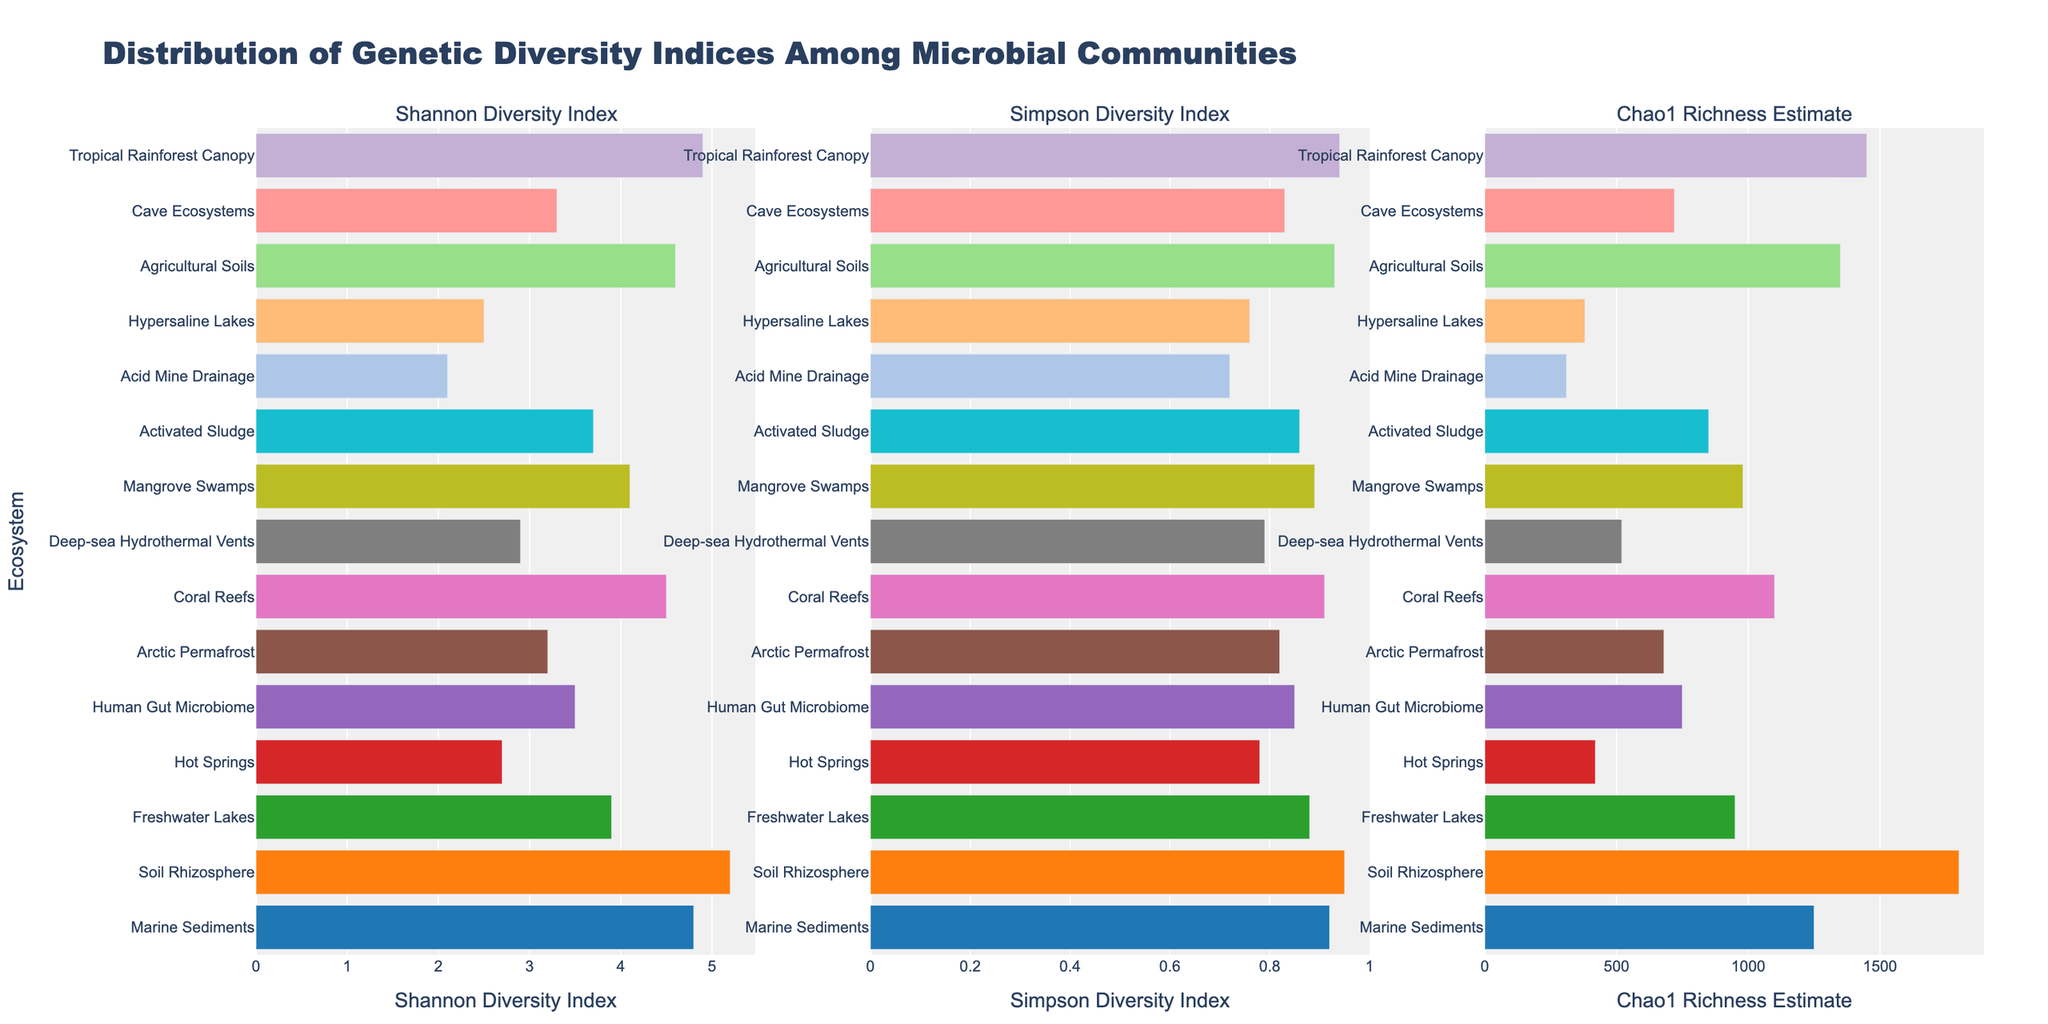Which ecosystem has the highest Shannon Diversity Index? To determine the ecosystem with the highest Shannon Diversity Index, look for the bar that extends the farthest to the right in the Shannon Diversity Index subplot. The Soil Rhizosphere bar is the longest, which represents a Shannon Diversity Index of 5.2.
Answer: Soil Rhizosphere Which ecosystem has the lowest Simpson Diversity Index? To identify the ecosystem with the lowest Simpson Diversity Index, observe which bar is the shortest in the Simpson Diversity Index subplot. The Acid Mine Drainage bar is the shortest, indicating a Simpson Diversity Index of 0.72.
Answer: Acid Mine Drainage How do the Shannon Diversity Index and Chao1 Richness Estimate of Agricultural Soils compare? Review the relative lengths of the bars for Agricultural Soils in both the Shannon Diversity Index and the Chao1 Richness Estimate subplots. The Shannon Diversity Index for Agricultural Soils is 4.6 (relatively long), while the Chao1 Richness Estimate is 1350 (moderately long, but shorter compared to some other ecosystems).
Answer: Shannon Diversity Index: 4.6, Chao1 Richness Estimate: 1350 What is the difference in Chao1 Richness Estimate between the Marine Sediments and Soil Rhizosphere? The Chao1 Richness Estimate for Marine Sediments is 1250 and for Soil Rhizosphere is 1800. The difference is calculated as 1800 - 1250.
Answer: 550 Which ecosystem has a higher Shannon Diversity Index, Freshwater Lakes or Mangrove Swamps? By examining the Shannon Diversity Index subplot, compare the lengths of the bars for Freshwater Lakes and Mangrove Swamps. Freshwater Lakes has a Shannon Diversity Index of 3.9, while Mangrove Swamps has a Shannon Diversity Index of 4.1, making Mangrove Swamps higher.
Answer: Mangrove Swamps Rank the top three ecosystems in terms of Simpson Diversity Index. Identify and order the three longest bars in the Simpson Diversity Index subplot. The top three ecosystems are Soil Rhizosphere (0.95), Tropical Rainforest Canopy (0.94), and Agricultural Soils (0.93).
Answer: 1. Soil Rhizosphere, 2. Tropical Rainforest Canopy, 3. Agricultural Soils Which two ecosystems have the closest Simpson Diversity Indicators? Compare the length of bars in the Simpson Diversity Index subplot to find the closest values. Coral Reefs (0.91) and Marine Sediments (0.92) have the closest values (0.01 difference).
Answer: Coral Reefs and Marine Sediments What is the sum of the Shannon Diversity Index values for Coral Reefs and Deep-sea Hydrothermal Vents? The Shannon Diversity Index for Coral Reefs is 4.5 and for Deep-sea Hydrothermal Vents is 2.9. The sum is 4.5 + 2.9.
Answer: 7.4 